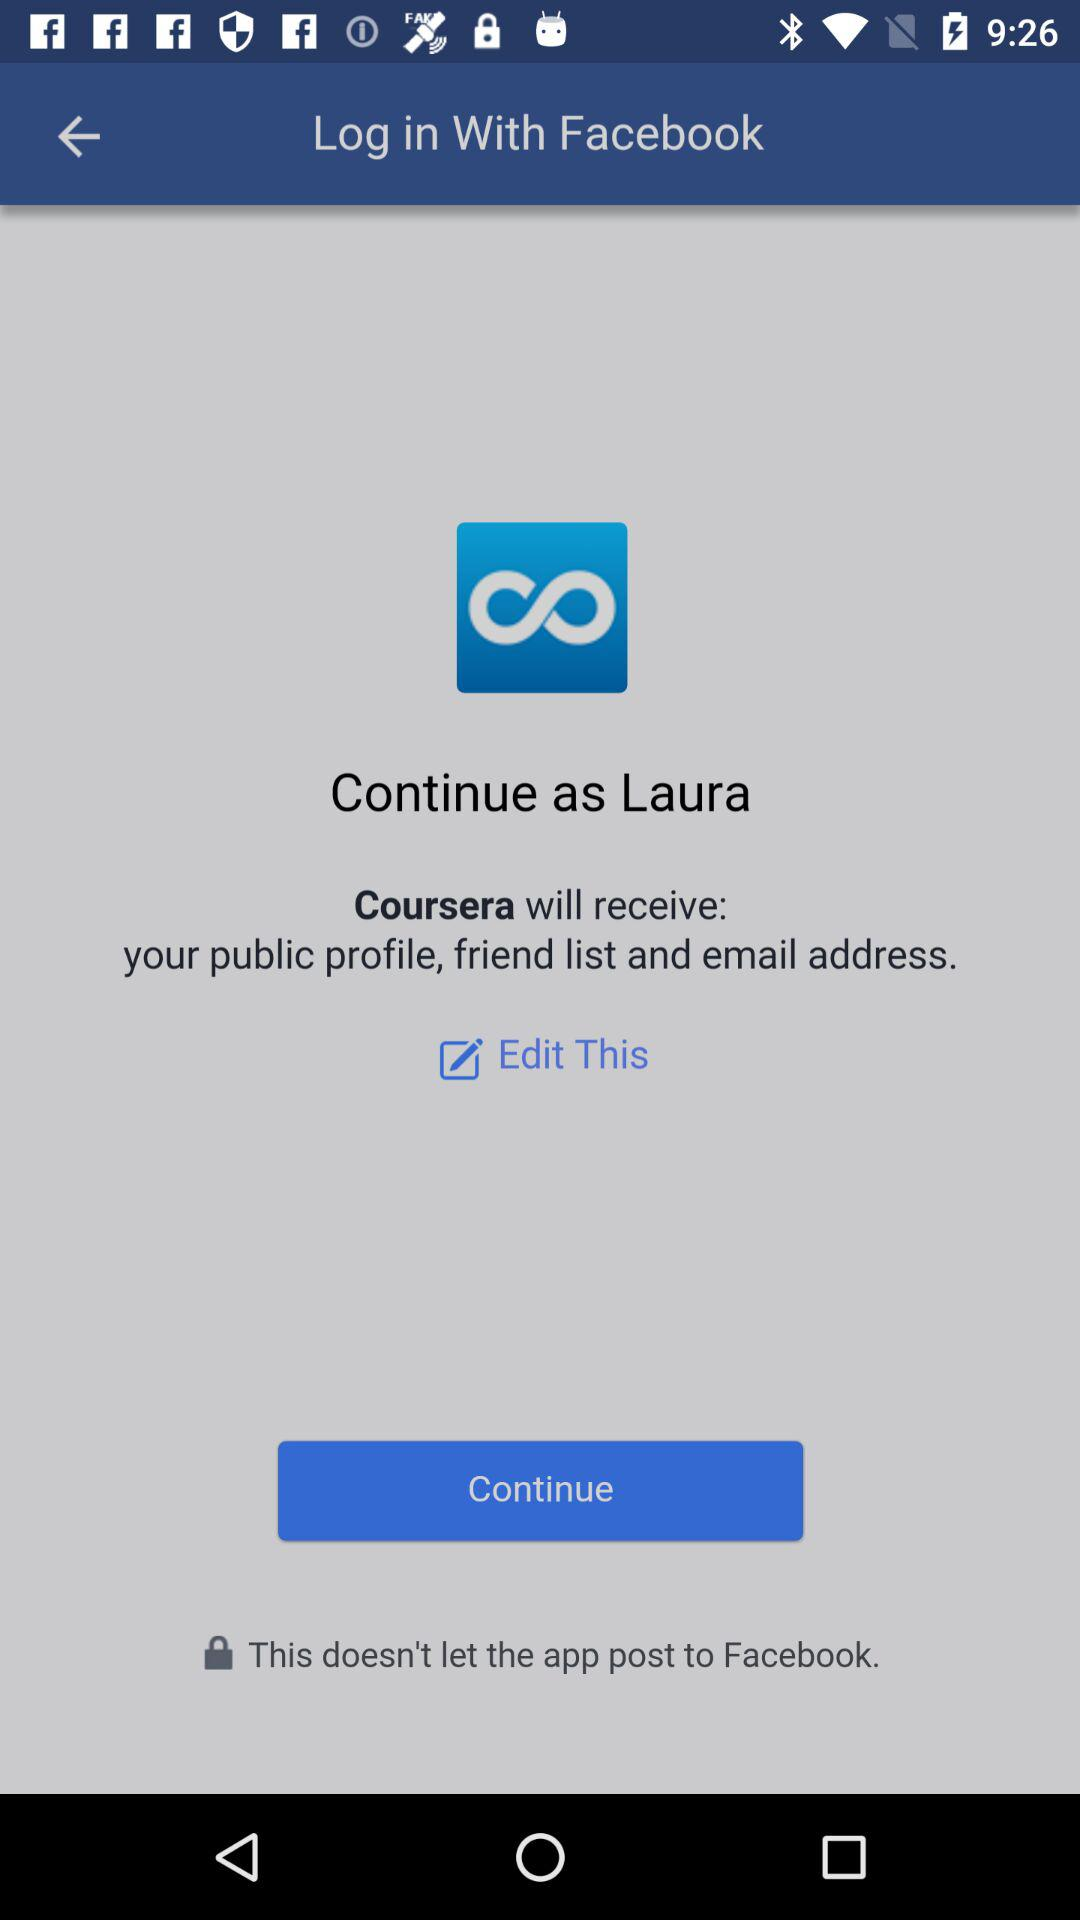What application receives the user's email address? The application is "Coursera". 